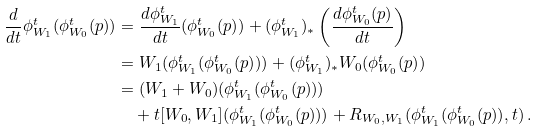<formula> <loc_0><loc_0><loc_500><loc_500>\frac { d } { d t } \phi ^ { t } _ { W _ { 1 } } ( \phi ^ { t } _ { W _ { 0 } } ( p ) ) & = \frac { d \phi _ { W _ { 1 } } ^ { t } } { d t } ( \phi ^ { t } _ { W _ { 0 } } ( p ) ) + ( \phi ^ { t } _ { W _ { 1 } } ) _ { * } \left ( \frac { d \phi _ { W _ { 0 } } ^ { t } ( p ) } { d t } \right ) \\ & = W _ { 1 } ( \phi _ { W _ { 1 } } ^ { t } ( \phi ^ { t } _ { W _ { 0 } } ( p ) ) ) + ( \phi ^ { t } _ { W _ { 1 } } ) _ { * } W _ { 0 } ( \phi ^ { t } _ { W _ { 0 } } ( p ) ) \\ & = ( W _ { 1 } + W _ { 0 } ) ( \phi _ { W _ { 1 } } ^ { t } ( \phi ^ { t } _ { W _ { 0 } } ( p ) ) ) \\ & \quad + t [ W _ { 0 } , W _ { 1 } ] ( \phi ^ { t } _ { W _ { 1 } } ( \phi ^ { t } _ { W _ { 0 } } ( p ) ) ) + R _ { W _ { 0 } , W _ { 1 } } ( \phi ^ { t } _ { W _ { 1 } } ( \phi ^ { t } _ { W _ { 0 } } ( p ) ) , t ) \, .</formula> 